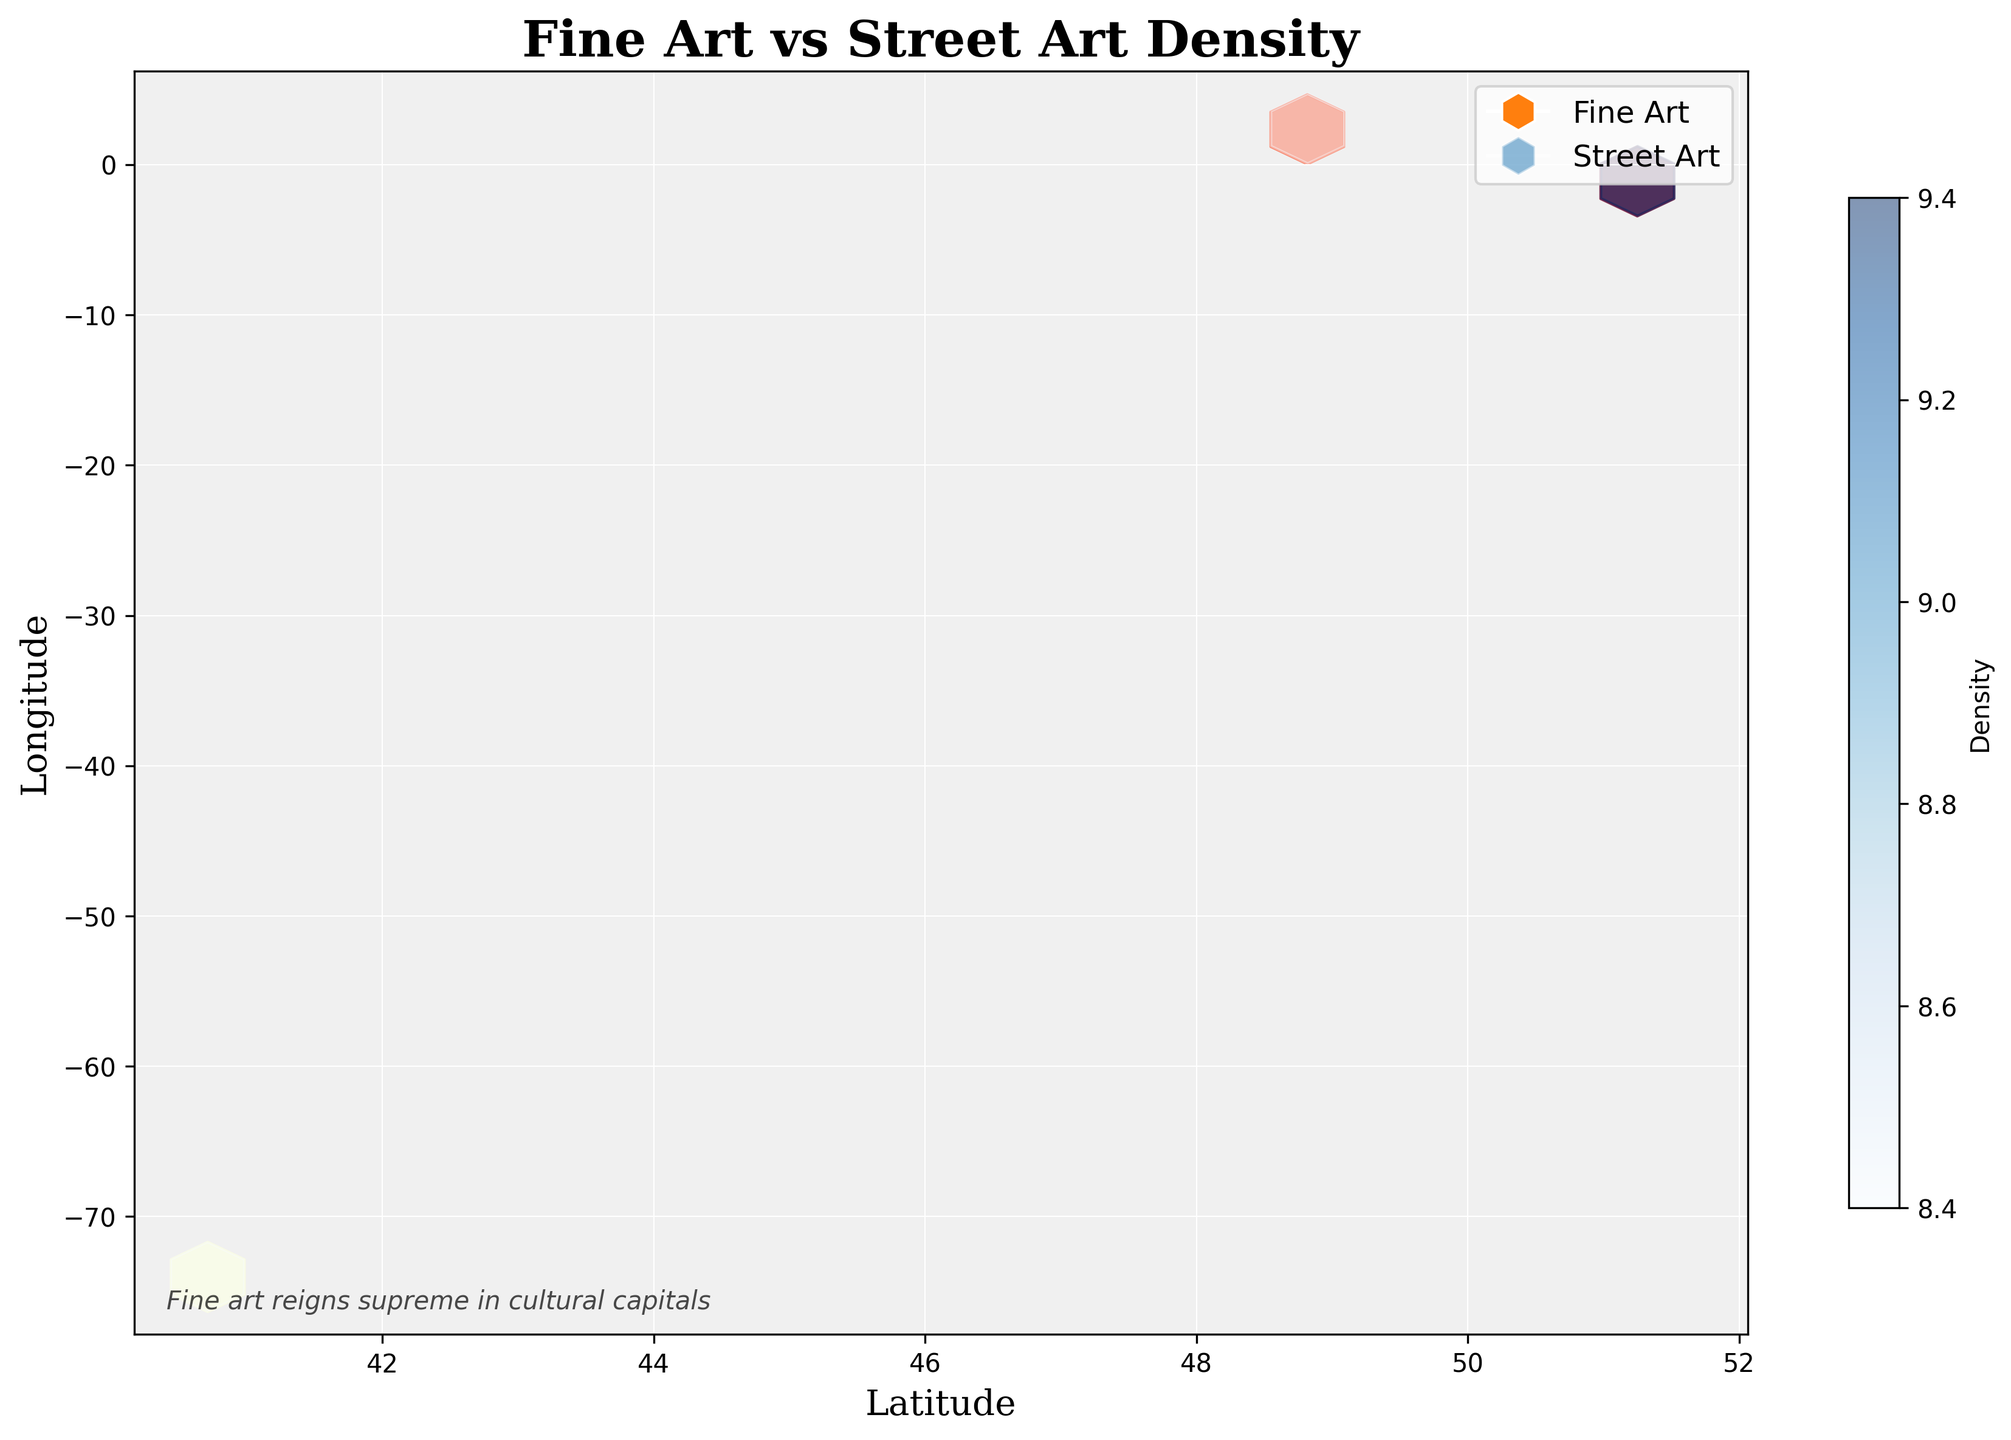What is the title of the figure? The title is typically located at the top of the figure.
Answer: Fine Art vs Street Art Density What are the labels on the x and y axes? The x-axis and y-axis labels are located along the bottom and left side of the plot, respectively.
Answer: Latitude, Longitude What do the colors in the hexagons represent? The colors in the hexagons are indicative of different density levels, with 'YlOrRd' (yellow to red) representing fine art and 'Blues' representing street art.
Answer: Density levels How does the density of Fine Art locations compare to Street Art in New York City? The areas of New York City (latitude ~40.71 to 40.76, longitude ~ -74.01 to -73.97) colored using the 'YlOrRd' scale are more concentrated than those using 'Blues', implying higher density of Fine Art locations compared to Street Art locations.
Answer: Higher Which type of art has higher density in London? Look at London (latitude ~51.50 to 51.52, longitude ~ -0.13 to -0.08). The hexagons with 'YlOrRd' shades are denser than those with 'Blues', indicating higher density of Fine Art locations.
Answer: Fine Art What is the relationship between location density and city regions for fine art versus street art? There are more densely packed regions of fine art (using 'YlOrRd') in central areas of major cities (New York, London, Paris), while street art (using 'Blues') is less densely packed and more evenly spread out.
Answer: Fine Art is denser in central areas What caption is present at the bottom of the figure? The caption, found at the bottom left, provides an interpretive statement about the data. It reads "Fine art reigns supreme in cultural capitals".
Answer: Fine art reigns supreme in cultural capitals 